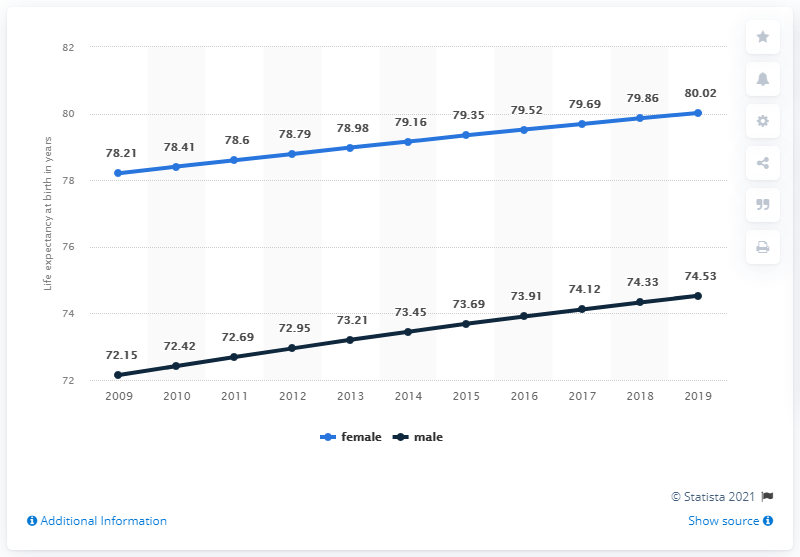Identify some key points in this picture. The sum of the first and last data points in the black line is 146.68. The lowest value in the blue bar line is 78.21. 